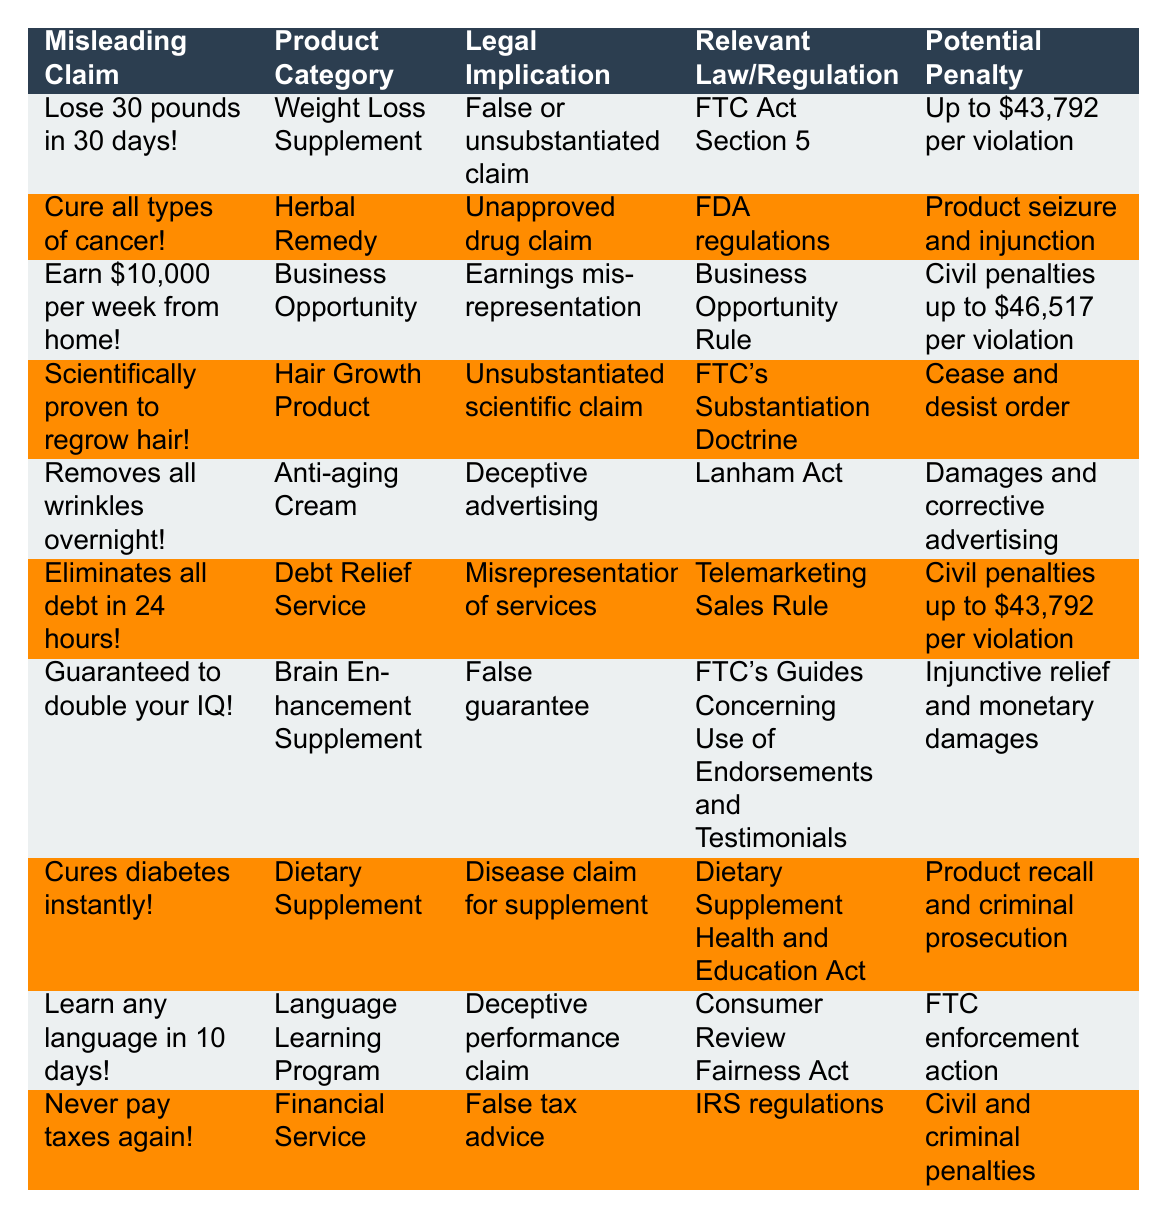What is the potential penalty for making a false guarantee regarding brain enhancement supplements? The table indicates that the potential penalty for falsely guaranteeing to double IQs falls under FTC's guidelines, which can result in injunctive relief and monetary damages, but no specific dollar amount is mentioned.
Answer: Injunctive relief and monetary damages Which product category has the highest potential penalty-related claim according to the table? By comparing the potential penalties listed, the highest specific penalty is $46,517 associated with earnings misrepresentation under the Business Opportunity Rule, which applies to business opportunities.
Answer: Business Opportunity Is the claim "Cures diabetes instantly!" regarded as a false drug claim according to any regulations? Yes, the claim relates to a dietary supplement and is classified as a disease claim for supplements under the Dietary Supplement Health and Education Act, which implies unapproved claims might be flagged.
Answer: Yes How many products claim to provide results that are "overnight" or "in an instant"? There are two products listed in the table that make claims involving very quick results: "Removes all wrinkles overnight!" and "Cures diabetes instantly!" totaling two claims.
Answer: 2 What is the legal implication of claiming that a weight loss supplement can help you lose 30 pounds in 30 days? This misleading claim is identified as a false or unsubstantiated claim under the FTC Act Section 5, which regulates deceptive practices in advertising.
Answer: False or unsubstantiated claim What is the common legal action taken against a product that claims to cure all types of cancer? The product claiming to cure all types of cancer faces an unapproved drug claim under FDA regulations, which could lead to product seizure and injunctions as legal actions.
Answer: Product seizure and injunction If someone claims they can eliminate all debt in 24 hours, what kind of legal action could they face? This claim will likely be viewed as a misrepresentation of services and could incur civil penalties up to $43,792 under the Telemarketing Sales Rule.
Answer: Civil penalties up to $43,792 What is the key regulation relevant to the claim "Earn $10,000 per week from home!"? The Business Opportunity Rule addresses this type of claim, which is associated with potential earnings misrepresentation in advertising.
Answer: Business Opportunity Rule Which infomercial claim can result in a product recall or criminal prosecution? The claim "Cures diabetes instantly!" is associated with serious legal implications under the Dietary Supplement Health and Education Act, which could result in product recall and even criminal prosecution.
Answer: Product recall and criminal prosecution Is the claim "Guaranteed to double your IQ!" considered deceptive according to any regulatory guidelines? Yes, it is categorized as a false guarantee under the FTC's Guides Concerning Use of Endorsements and Testimonials, making it potentially deceptive.
Answer: Yes What is the average potential penalty across all claims in the table that have a specified monetary value? To find the average, add the specified penalties ($43,792 + $46,517 + $43,792) divided by the three claims that list penalties, resulting in an average penalty of $44,367.67.
Answer: $44,367.67 